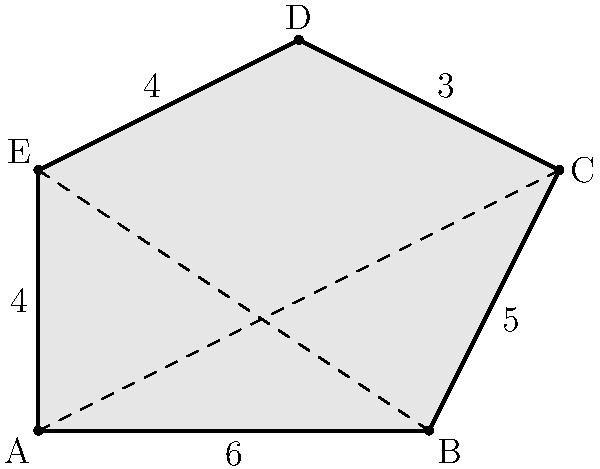In an adaptive architecture project, you're tasked with designing a uniquely shaped solar panel for maximum energy efficiency. The panel's shape is represented by the irregular pentagon ABCDE shown above. Given that AB = 6 units, BC = 5 units, CD = 3 units, DE = 4 units, and EA = 4 units, calculate the area of this solar panel. How might this unconventional shape impact the future of sustainable building design? To calculate the area of this irregular pentagon, we can use the triangulation method:

1. Divide the pentagon into three triangles by drawing diagonals AC and BE.

2. Calculate the areas of these triangles using Heron's formula:
   $A = \sqrt{s(s-a)(s-b)(s-c)}$, where $s = \frac{a+b+c}{2}$ (semi-perimeter)

3. For triangle ABC:
   $s = \frac{6+5+\sqrt{6^2+5^2}}{2} = \frac{11+\sqrt{61}}{2}$
   $A_{ABC} = \sqrt{\frac{11+\sqrt{61}}{2} \cdot \frac{5-\sqrt{61}}{2} \cdot \frac{-1+\sqrt{61}}{2} \cdot \frac{5+\sqrt{61}}{2}}$

4. For triangle ACD:
   $s = \frac{\sqrt{61}+3+4}{2} = \frac{\sqrt{61}+7}{2}$
   $A_{ACD} = \sqrt{\frac{\sqrt{61}+7}{2} \cdot \frac{\sqrt{61}-1}{2} \cdot \frac{\sqrt{61}+1}{2} \cdot \frac{-\sqrt{61}+7}{2}}$

5. For triangle ADE:
   $s = \frac{4+4+4}{2} = 6$
   $A_{ADE} = \sqrt{6 \cdot 2 \cdot 2 \cdot 2} = 4\sqrt{3}$

6. Total area = $A_{ABC} + A_{ACD} + A_{ADE}$

The exact result involves complex radicals, but can be approximated numerically.

This unconventional shape could impact sustainable building design by:
1. Maximizing surface area for solar energy capture
2. Adapting to specific environmental conditions or building structures
3. Inspiring new aesthetics in architectural design
4. Encouraging innovation in manufacturing processes for solar panels
Answer: Approximately 22.16 square units 